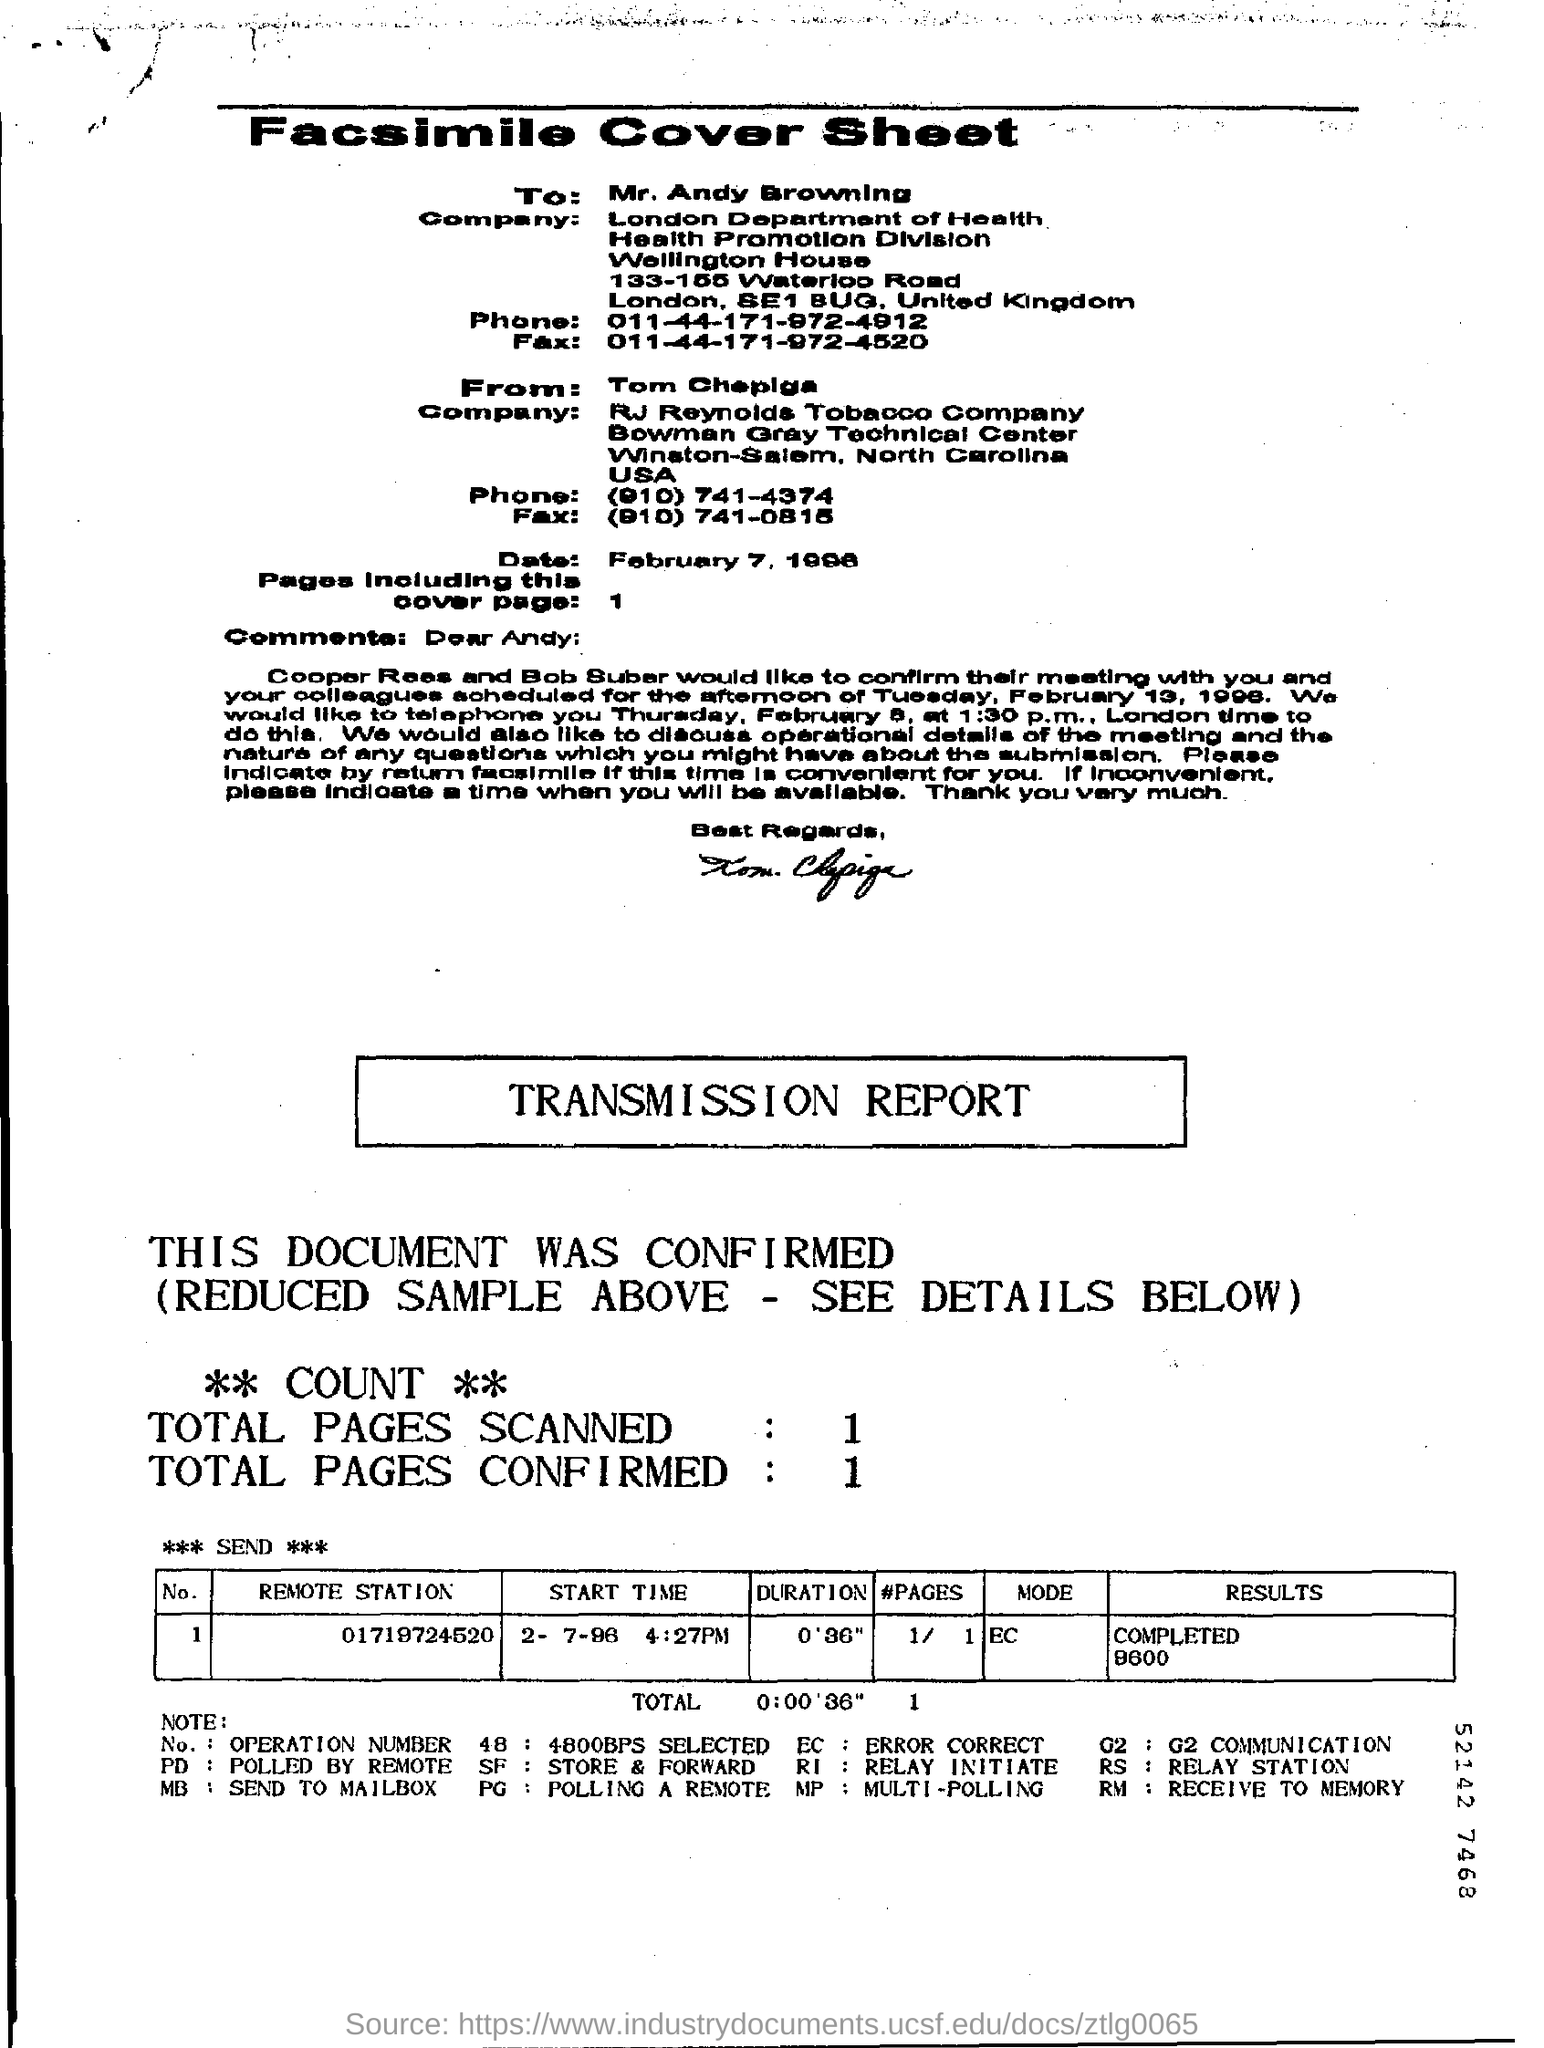Outline some significant characteristics in this image. The remote station's number is 01719724520. The company name of Tom Chepiga is RJ Reynolds Tobacco Company. The duration in the transmission report is 0'36". 